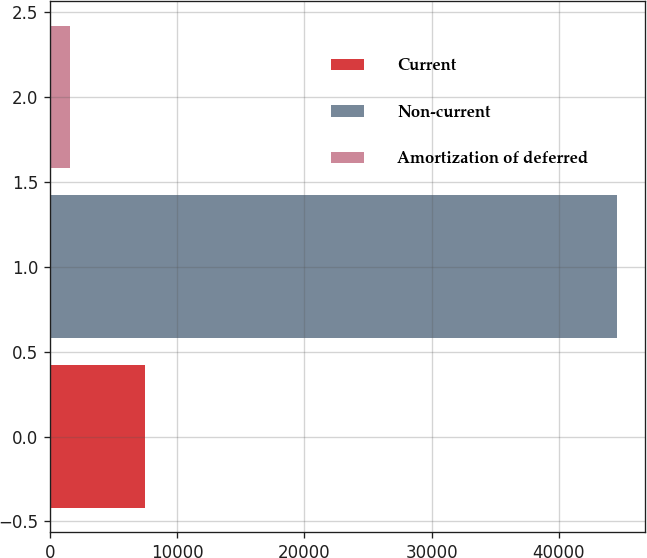Convert chart to OTSL. <chart><loc_0><loc_0><loc_500><loc_500><bar_chart><fcel>Current<fcel>Non-current<fcel>Amortization of deferred<nl><fcel>7440<fcel>44576<fcel>1542<nl></chart> 